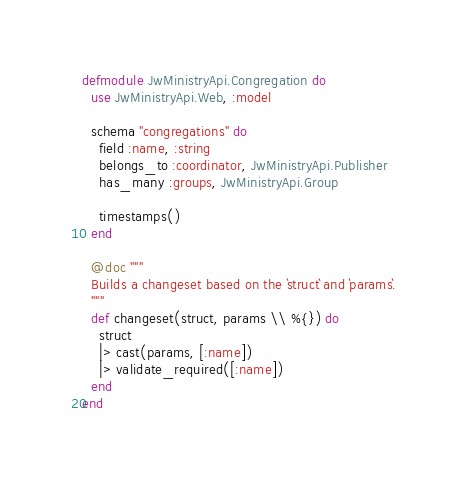<code> <loc_0><loc_0><loc_500><loc_500><_Elixir_>defmodule JwMinistryApi.Congregation do
  use JwMinistryApi.Web, :model

  schema "congregations" do
    field :name, :string
    belongs_to :coordinator, JwMinistryApi.Publisher
    has_many :groups, JwMinistryApi.Group

    timestamps()
  end

  @doc """
  Builds a changeset based on the `struct` and `params`.
  """
  def changeset(struct, params \\ %{}) do
    struct
    |> cast(params, [:name])
    |> validate_required([:name])
  end
end
</code> 